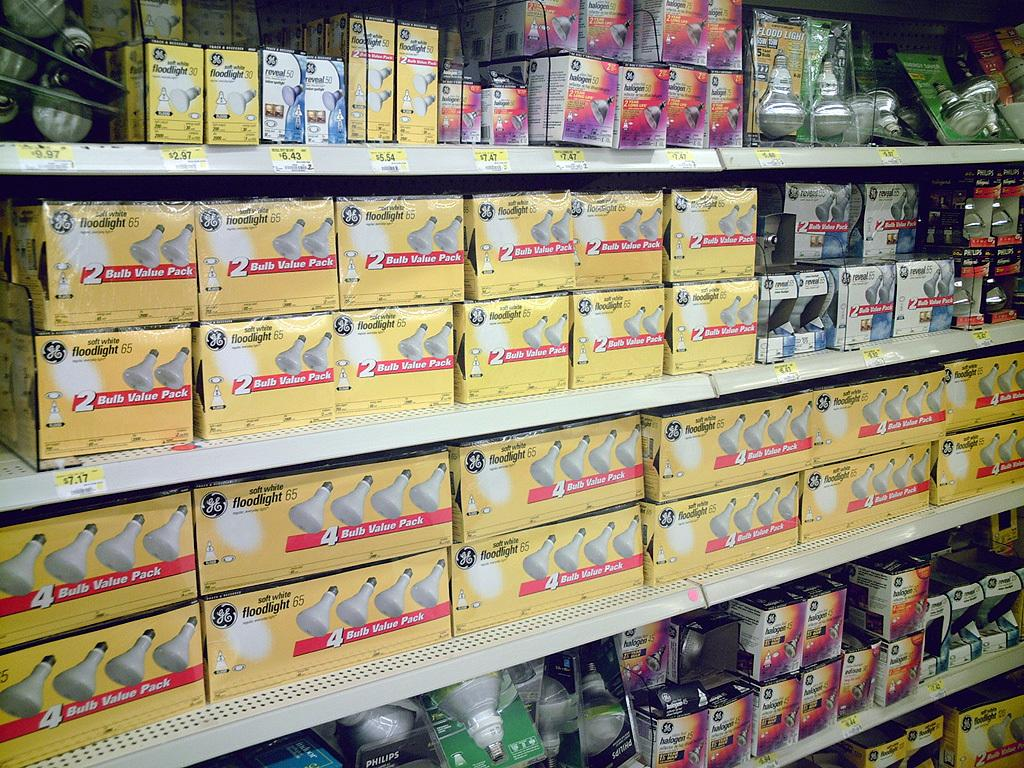What type of structure is present in the image? There are racks in the image. What can be found on the racks? There are boxes with labels and text on the racks. Are there any other objects visible in the image? Yes, there are bulbs in the image. What type of weather can be seen in the image? There is no weather visible in the image; it is an indoor scene with racks, boxes, and bulbs. Is there a cake present in the image? No, there is no cake visible in the image. 